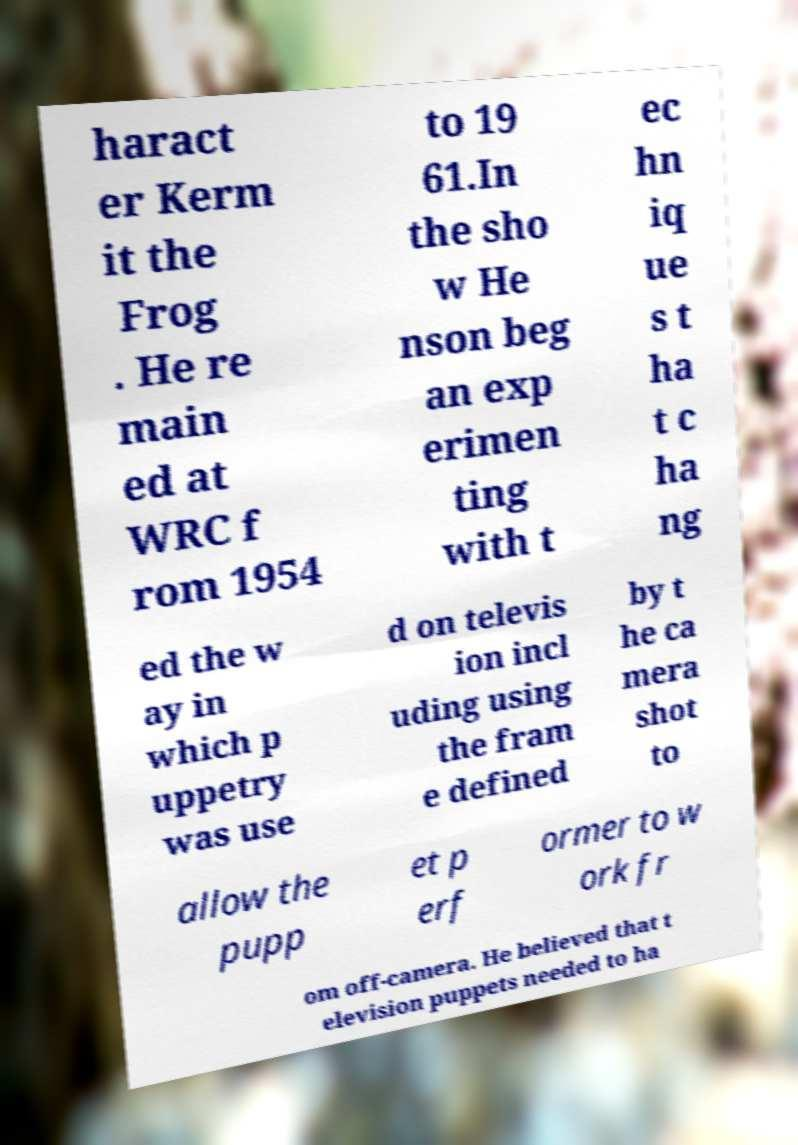Can you read and provide the text displayed in the image?This photo seems to have some interesting text. Can you extract and type it out for me? haract er Kerm it the Frog . He re main ed at WRC f rom 1954 to 19 61.In the sho w He nson beg an exp erimen ting with t ec hn iq ue s t ha t c ha ng ed the w ay in which p uppetry was use d on televis ion incl uding using the fram e defined by t he ca mera shot to allow the pupp et p erf ormer to w ork fr om off-camera. He believed that t elevision puppets needed to ha 